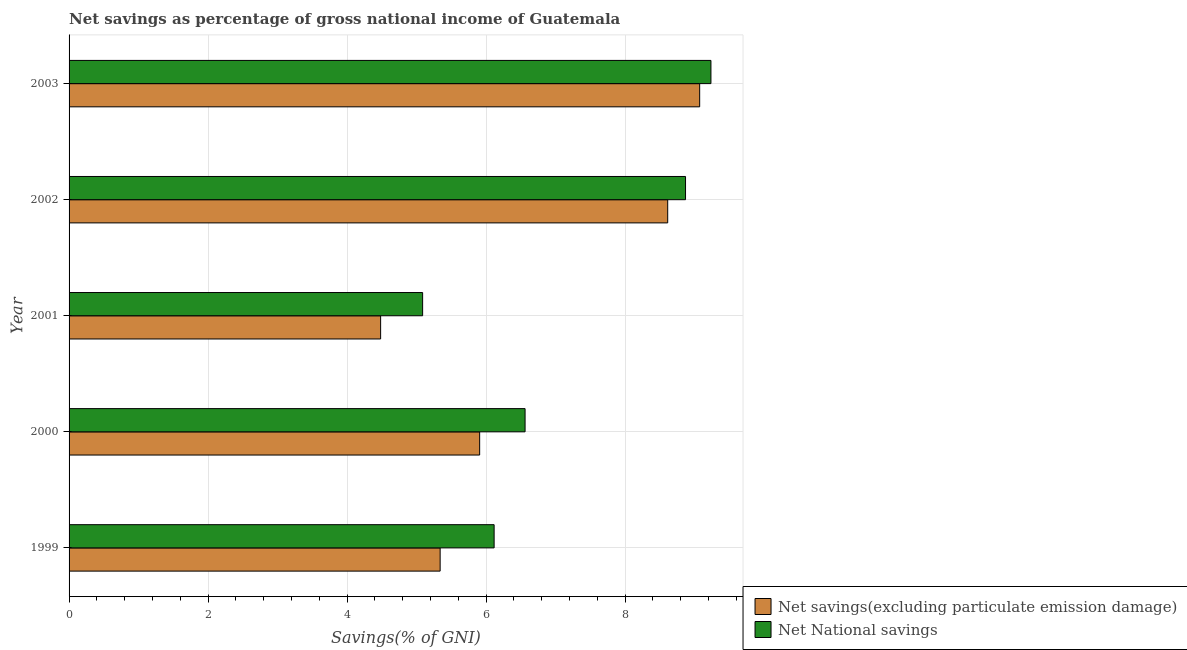How many different coloured bars are there?
Provide a succinct answer. 2. Are the number of bars per tick equal to the number of legend labels?
Offer a very short reply. Yes. What is the label of the 3rd group of bars from the top?
Provide a succinct answer. 2001. What is the net savings(excluding particulate emission damage) in 2002?
Make the answer very short. 8.61. Across all years, what is the maximum net national savings?
Your answer should be compact. 9.24. Across all years, what is the minimum net savings(excluding particulate emission damage)?
Offer a very short reply. 4.48. In which year was the net national savings maximum?
Your answer should be very brief. 2003. In which year was the net savings(excluding particulate emission damage) minimum?
Offer a terse response. 2001. What is the total net savings(excluding particulate emission damage) in the graph?
Your answer should be very brief. 33.42. What is the difference between the net savings(excluding particulate emission damage) in 2000 and that in 2003?
Ensure brevity in your answer.  -3.17. What is the difference between the net national savings in 2002 and the net savings(excluding particulate emission damage) in 2001?
Your answer should be compact. 4.39. What is the average net national savings per year?
Keep it short and to the point. 7.17. In the year 2003, what is the difference between the net national savings and net savings(excluding particulate emission damage)?
Make the answer very short. 0.16. In how many years, is the net savings(excluding particulate emission damage) greater than 3.2 %?
Your answer should be very brief. 5. What is the ratio of the net national savings in 1999 to that in 2000?
Make the answer very short. 0.93. Is the difference between the net national savings in 2000 and 2003 greater than the difference between the net savings(excluding particulate emission damage) in 2000 and 2003?
Ensure brevity in your answer.  Yes. What is the difference between the highest and the second highest net savings(excluding particulate emission damage)?
Your response must be concise. 0.46. What is the difference between the highest and the lowest net savings(excluding particulate emission damage)?
Your answer should be compact. 4.59. What does the 1st bar from the top in 2003 represents?
Ensure brevity in your answer.  Net National savings. What does the 1st bar from the bottom in 2002 represents?
Offer a terse response. Net savings(excluding particulate emission damage). How many bars are there?
Give a very brief answer. 10. Does the graph contain grids?
Your response must be concise. Yes. Where does the legend appear in the graph?
Make the answer very short. Bottom right. How many legend labels are there?
Your response must be concise. 2. What is the title of the graph?
Offer a terse response. Net savings as percentage of gross national income of Guatemala. What is the label or title of the X-axis?
Provide a short and direct response. Savings(% of GNI). What is the label or title of the Y-axis?
Offer a terse response. Year. What is the Savings(% of GNI) of Net savings(excluding particulate emission damage) in 1999?
Keep it short and to the point. 5.34. What is the Savings(% of GNI) of Net National savings in 1999?
Give a very brief answer. 6.12. What is the Savings(% of GNI) of Net savings(excluding particulate emission damage) in 2000?
Your answer should be compact. 5.91. What is the Savings(% of GNI) in Net National savings in 2000?
Your response must be concise. 6.56. What is the Savings(% of GNI) of Net savings(excluding particulate emission damage) in 2001?
Make the answer very short. 4.48. What is the Savings(% of GNI) of Net National savings in 2001?
Make the answer very short. 5.09. What is the Savings(% of GNI) of Net savings(excluding particulate emission damage) in 2002?
Provide a succinct answer. 8.61. What is the Savings(% of GNI) in Net National savings in 2002?
Make the answer very short. 8.87. What is the Savings(% of GNI) of Net savings(excluding particulate emission damage) in 2003?
Offer a terse response. 9.07. What is the Savings(% of GNI) in Net National savings in 2003?
Provide a short and direct response. 9.24. Across all years, what is the maximum Savings(% of GNI) in Net savings(excluding particulate emission damage)?
Your answer should be very brief. 9.07. Across all years, what is the maximum Savings(% of GNI) of Net National savings?
Make the answer very short. 9.24. Across all years, what is the minimum Savings(% of GNI) of Net savings(excluding particulate emission damage)?
Provide a short and direct response. 4.48. Across all years, what is the minimum Savings(% of GNI) of Net National savings?
Keep it short and to the point. 5.09. What is the total Savings(% of GNI) in Net savings(excluding particulate emission damage) in the graph?
Your response must be concise. 33.42. What is the total Savings(% of GNI) of Net National savings in the graph?
Keep it short and to the point. 35.87. What is the difference between the Savings(% of GNI) in Net savings(excluding particulate emission damage) in 1999 and that in 2000?
Offer a very short reply. -0.57. What is the difference between the Savings(% of GNI) in Net National savings in 1999 and that in 2000?
Keep it short and to the point. -0.45. What is the difference between the Savings(% of GNI) of Net savings(excluding particulate emission damage) in 1999 and that in 2001?
Offer a terse response. 0.86. What is the difference between the Savings(% of GNI) of Net National savings in 1999 and that in 2001?
Your answer should be very brief. 1.03. What is the difference between the Savings(% of GNI) in Net savings(excluding particulate emission damage) in 1999 and that in 2002?
Provide a succinct answer. -3.27. What is the difference between the Savings(% of GNI) of Net National savings in 1999 and that in 2002?
Ensure brevity in your answer.  -2.75. What is the difference between the Savings(% of GNI) in Net savings(excluding particulate emission damage) in 1999 and that in 2003?
Ensure brevity in your answer.  -3.73. What is the difference between the Savings(% of GNI) of Net National savings in 1999 and that in 2003?
Offer a terse response. -3.12. What is the difference between the Savings(% of GNI) in Net savings(excluding particulate emission damage) in 2000 and that in 2001?
Offer a very short reply. 1.42. What is the difference between the Savings(% of GNI) in Net National savings in 2000 and that in 2001?
Keep it short and to the point. 1.47. What is the difference between the Savings(% of GNI) in Net savings(excluding particulate emission damage) in 2000 and that in 2002?
Your answer should be compact. -2.71. What is the difference between the Savings(% of GNI) in Net National savings in 2000 and that in 2002?
Give a very brief answer. -2.31. What is the difference between the Savings(% of GNI) in Net savings(excluding particulate emission damage) in 2000 and that in 2003?
Offer a terse response. -3.17. What is the difference between the Savings(% of GNI) in Net National savings in 2000 and that in 2003?
Provide a succinct answer. -2.67. What is the difference between the Savings(% of GNI) of Net savings(excluding particulate emission damage) in 2001 and that in 2002?
Ensure brevity in your answer.  -4.13. What is the difference between the Savings(% of GNI) in Net National savings in 2001 and that in 2002?
Your answer should be very brief. -3.78. What is the difference between the Savings(% of GNI) of Net savings(excluding particulate emission damage) in 2001 and that in 2003?
Your answer should be compact. -4.59. What is the difference between the Savings(% of GNI) in Net National savings in 2001 and that in 2003?
Offer a terse response. -4.15. What is the difference between the Savings(% of GNI) of Net savings(excluding particulate emission damage) in 2002 and that in 2003?
Your answer should be very brief. -0.46. What is the difference between the Savings(% of GNI) in Net National savings in 2002 and that in 2003?
Offer a terse response. -0.37. What is the difference between the Savings(% of GNI) of Net savings(excluding particulate emission damage) in 1999 and the Savings(% of GNI) of Net National savings in 2000?
Offer a terse response. -1.22. What is the difference between the Savings(% of GNI) in Net savings(excluding particulate emission damage) in 1999 and the Savings(% of GNI) in Net National savings in 2001?
Your answer should be very brief. 0.25. What is the difference between the Savings(% of GNI) of Net savings(excluding particulate emission damage) in 1999 and the Savings(% of GNI) of Net National savings in 2002?
Your response must be concise. -3.53. What is the difference between the Savings(% of GNI) of Net savings(excluding particulate emission damage) in 1999 and the Savings(% of GNI) of Net National savings in 2003?
Keep it short and to the point. -3.9. What is the difference between the Savings(% of GNI) of Net savings(excluding particulate emission damage) in 2000 and the Savings(% of GNI) of Net National savings in 2001?
Provide a short and direct response. 0.82. What is the difference between the Savings(% of GNI) of Net savings(excluding particulate emission damage) in 2000 and the Savings(% of GNI) of Net National savings in 2002?
Keep it short and to the point. -2.96. What is the difference between the Savings(% of GNI) in Net savings(excluding particulate emission damage) in 2000 and the Savings(% of GNI) in Net National savings in 2003?
Keep it short and to the point. -3.33. What is the difference between the Savings(% of GNI) in Net savings(excluding particulate emission damage) in 2001 and the Savings(% of GNI) in Net National savings in 2002?
Offer a very short reply. -4.39. What is the difference between the Savings(% of GNI) in Net savings(excluding particulate emission damage) in 2001 and the Savings(% of GNI) in Net National savings in 2003?
Keep it short and to the point. -4.75. What is the difference between the Savings(% of GNI) in Net savings(excluding particulate emission damage) in 2002 and the Savings(% of GNI) in Net National savings in 2003?
Provide a succinct answer. -0.62. What is the average Savings(% of GNI) of Net savings(excluding particulate emission damage) per year?
Keep it short and to the point. 6.68. What is the average Savings(% of GNI) of Net National savings per year?
Ensure brevity in your answer.  7.17. In the year 1999, what is the difference between the Savings(% of GNI) in Net savings(excluding particulate emission damage) and Savings(% of GNI) in Net National savings?
Your answer should be compact. -0.78. In the year 2000, what is the difference between the Savings(% of GNI) of Net savings(excluding particulate emission damage) and Savings(% of GNI) of Net National savings?
Provide a succinct answer. -0.65. In the year 2001, what is the difference between the Savings(% of GNI) in Net savings(excluding particulate emission damage) and Savings(% of GNI) in Net National savings?
Make the answer very short. -0.6. In the year 2002, what is the difference between the Savings(% of GNI) in Net savings(excluding particulate emission damage) and Savings(% of GNI) in Net National savings?
Make the answer very short. -0.26. In the year 2003, what is the difference between the Savings(% of GNI) of Net savings(excluding particulate emission damage) and Savings(% of GNI) of Net National savings?
Keep it short and to the point. -0.16. What is the ratio of the Savings(% of GNI) in Net savings(excluding particulate emission damage) in 1999 to that in 2000?
Provide a succinct answer. 0.9. What is the ratio of the Savings(% of GNI) of Net National savings in 1999 to that in 2000?
Provide a succinct answer. 0.93. What is the ratio of the Savings(% of GNI) of Net savings(excluding particulate emission damage) in 1999 to that in 2001?
Offer a terse response. 1.19. What is the ratio of the Savings(% of GNI) in Net National savings in 1999 to that in 2001?
Offer a terse response. 1.2. What is the ratio of the Savings(% of GNI) in Net savings(excluding particulate emission damage) in 1999 to that in 2002?
Offer a terse response. 0.62. What is the ratio of the Savings(% of GNI) of Net National savings in 1999 to that in 2002?
Your response must be concise. 0.69. What is the ratio of the Savings(% of GNI) in Net savings(excluding particulate emission damage) in 1999 to that in 2003?
Give a very brief answer. 0.59. What is the ratio of the Savings(% of GNI) of Net National savings in 1999 to that in 2003?
Ensure brevity in your answer.  0.66. What is the ratio of the Savings(% of GNI) in Net savings(excluding particulate emission damage) in 2000 to that in 2001?
Offer a terse response. 1.32. What is the ratio of the Savings(% of GNI) in Net National savings in 2000 to that in 2001?
Offer a very short reply. 1.29. What is the ratio of the Savings(% of GNI) of Net savings(excluding particulate emission damage) in 2000 to that in 2002?
Ensure brevity in your answer.  0.69. What is the ratio of the Savings(% of GNI) of Net National savings in 2000 to that in 2002?
Provide a succinct answer. 0.74. What is the ratio of the Savings(% of GNI) in Net savings(excluding particulate emission damage) in 2000 to that in 2003?
Make the answer very short. 0.65. What is the ratio of the Savings(% of GNI) of Net National savings in 2000 to that in 2003?
Provide a succinct answer. 0.71. What is the ratio of the Savings(% of GNI) of Net savings(excluding particulate emission damage) in 2001 to that in 2002?
Give a very brief answer. 0.52. What is the ratio of the Savings(% of GNI) in Net National savings in 2001 to that in 2002?
Your answer should be compact. 0.57. What is the ratio of the Savings(% of GNI) in Net savings(excluding particulate emission damage) in 2001 to that in 2003?
Give a very brief answer. 0.49. What is the ratio of the Savings(% of GNI) in Net National savings in 2001 to that in 2003?
Provide a short and direct response. 0.55. What is the ratio of the Savings(% of GNI) in Net savings(excluding particulate emission damage) in 2002 to that in 2003?
Offer a terse response. 0.95. What is the ratio of the Savings(% of GNI) of Net National savings in 2002 to that in 2003?
Make the answer very short. 0.96. What is the difference between the highest and the second highest Savings(% of GNI) in Net savings(excluding particulate emission damage)?
Give a very brief answer. 0.46. What is the difference between the highest and the second highest Savings(% of GNI) of Net National savings?
Provide a short and direct response. 0.37. What is the difference between the highest and the lowest Savings(% of GNI) of Net savings(excluding particulate emission damage)?
Your answer should be very brief. 4.59. What is the difference between the highest and the lowest Savings(% of GNI) in Net National savings?
Keep it short and to the point. 4.15. 